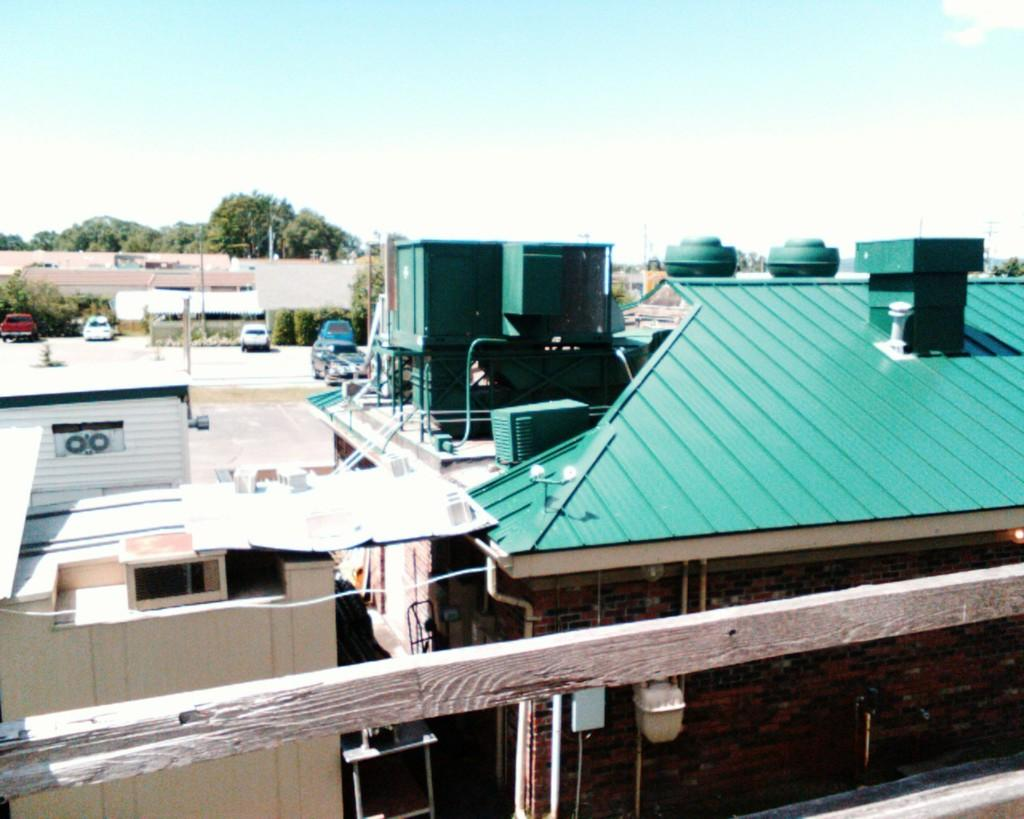What type of barrier is at the bottom of the image? There is a wooden fence at the bottom of the image. What can be seen in the distance in the image? There are buildings and vehicles in the background of the image. What type of vegetation is visible in the background of the image? Trees are visible on the ground in the background of the image. How would you describe the sky in the image? The sky is blue and has clouds in it. Where is the family sitting on the swing in the image? There is no family or swing present in the image; it only shows a wooden fence, buildings, vehicles, trees, and a blue sky with clouds. 